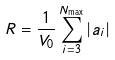<formula> <loc_0><loc_0><loc_500><loc_500>R = \frac { 1 } { V _ { 0 } } \sum _ { i = 3 } ^ { N _ { \max } } | a _ { i } |</formula> 